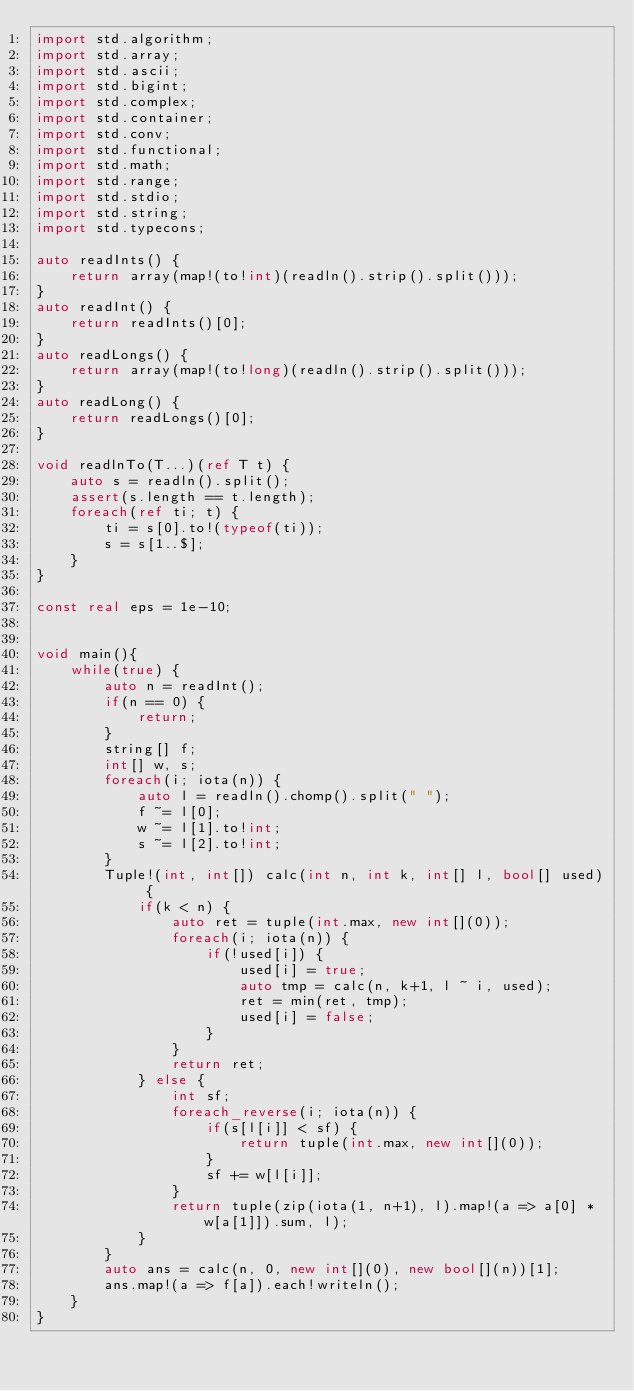<code> <loc_0><loc_0><loc_500><loc_500><_D_>import std.algorithm;
import std.array;
import std.ascii;
import std.bigint;
import std.complex;
import std.container;
import std.conv;
import std.functional;
import std.math;
import std.range;
import std.stdio;
import std.string;
import std.typecons;

auto readInts() {
	return array(map!(to!int)(readln().strip().split()));
}
auto readInt() {
	return readInts()[0];
}
auto readLongs() {
	return array(map!(to!long)(readln().strip().split()));
}
auto readLong() {
	return readLongs()[0];
}

void readlnTo(T...)(ref T t) {
    auto s = readln().split();
    assert(s.length == t.length);
    foreach(ref ti; t) {
        ti = s[0].to!(typeof(ti));
        s = s[1..$];
    }
}

const real eps = 1e-10;


void main(){
    while(true) {
        auto n = readInt();
        if(n == 0) {
            return;
        }
        string[] f;
        int[] w, s;
        foreach(i; iota(n)) {
            auto l = readln().chomp().split(" ");
            f ~= l[0];
            w ~= l[1].to!int;
            s ~= l[2].to!int;
        }
        Tuple!(int, int[]) calc(int n, int k, int[] l, bool[] used) {
            if(k < n) {
                auto ret = tuple(int.max, new int[](0));
                foreach(i; iota(n)) {
                    if(!used[i]) {
                        used[i] = true;
                        auto tmp = calc(n, k+1, l ~ i, used);
                        ret = min(ret, tmp);
                        used[i] = false;
                    }
                }
                return ret;
            } else {
                int sf;
                foreach_reverse(i; iota(n)) {
                    if(s[l[i]] < sf) {
                        return tuple(int.max, new int[](0));
                    }
                    sf += w[l[i]];
                }
                return tuple(zip(iota(1, n+1), l).map!(a => a[0] * w[a[1]]).sum, l);
            }
        }
        auto ans = calc(n, 0, new int[](0), new bool[](n))[1];
        ans.map!(a => f[a]).each!writeln();
    }
}</code> 